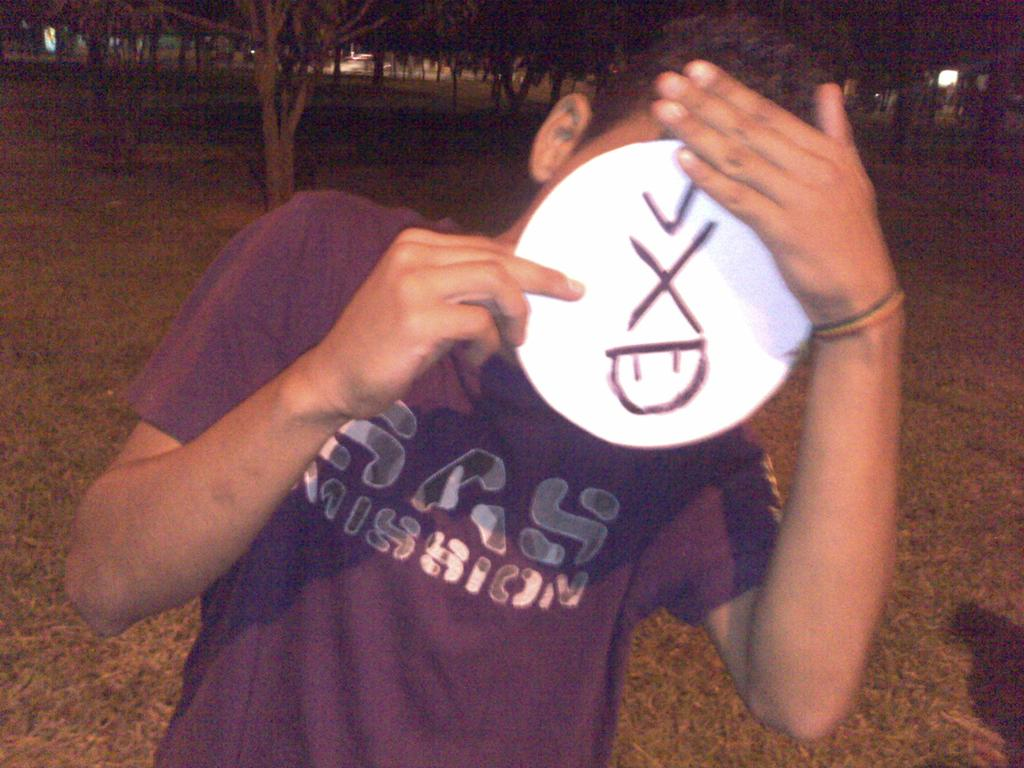<image>
Summarize the visual content of the image. Person wearing a purple shirt that says SAS Mission covering their face. 